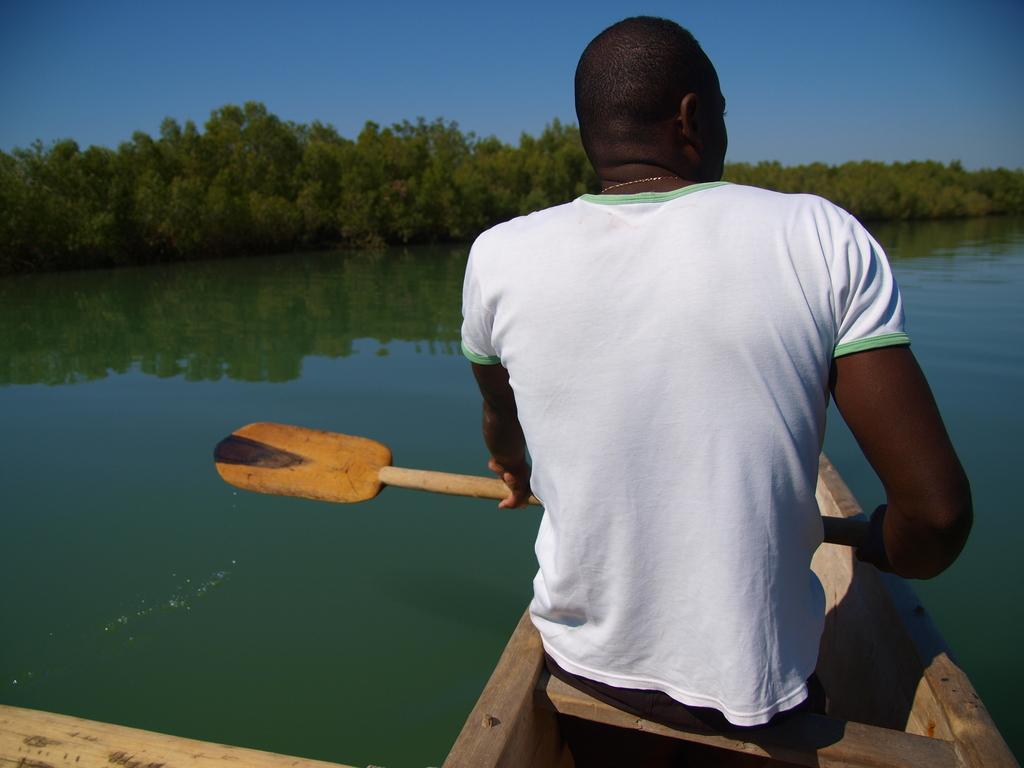Please provide a concise description of this image. In this image we can see a person wearing white T-shirt is sitting in the boat and holding the paddle. Here we can see the water, trees and the blue color sky in the background. 